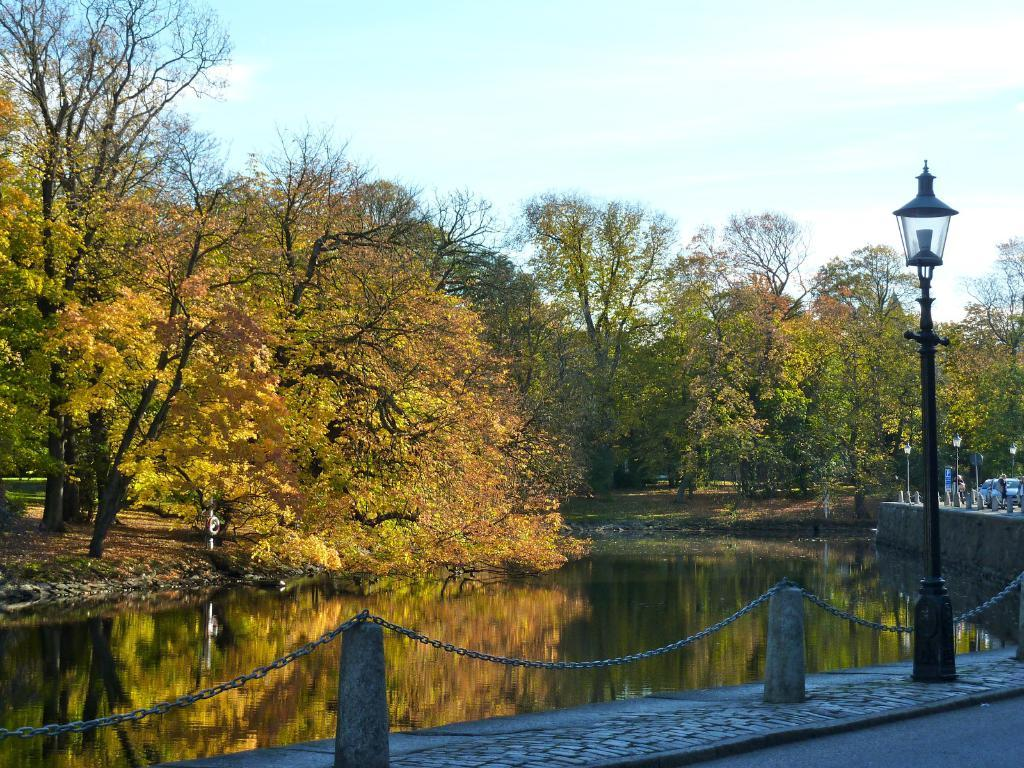What is the primary element visible in the image? There is water in the image. What objects are present in the water? There is a chain and poles in the water. What additional features can be seen in the image? There are lights, cars, two persons, trees in the background, and the sky visible in the background. How many minutes does it take for the sweater to dry in the image? There is no sweater present in the image, so it is not possible to determine how long it would take to dry. 